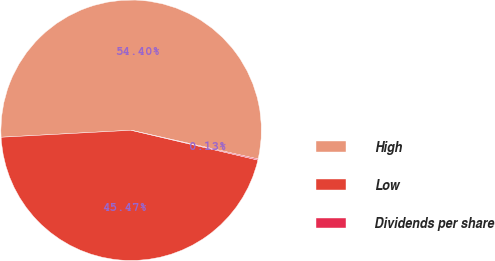Convert chart. <chart><loc_0><loc_0><loc_500><loc_500><pie_chart><fcel>High<fcel>Low<fcel>Dividends per share<nl><fcel>54.4%<fcel>45.47%<fcel>0.13%<nl></chart> 